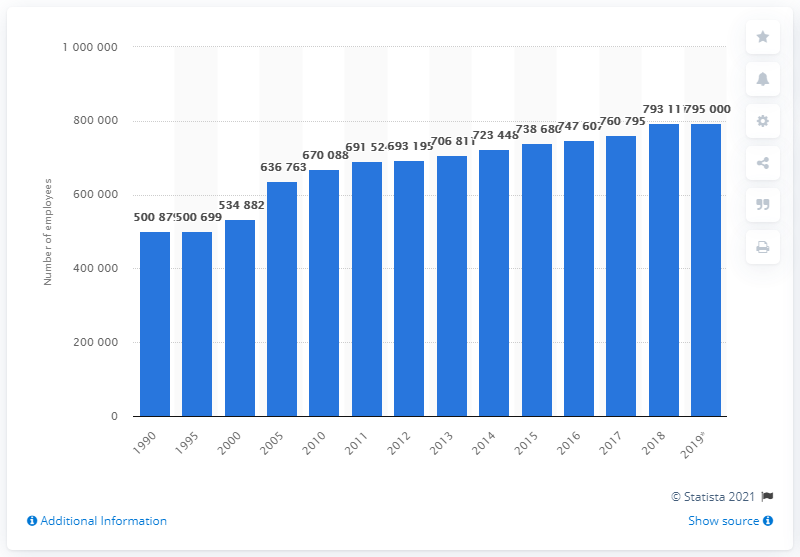Give some essential details in this illustration. In 2005, the pharmaceutical industry in Europe employed 760,795 people. 